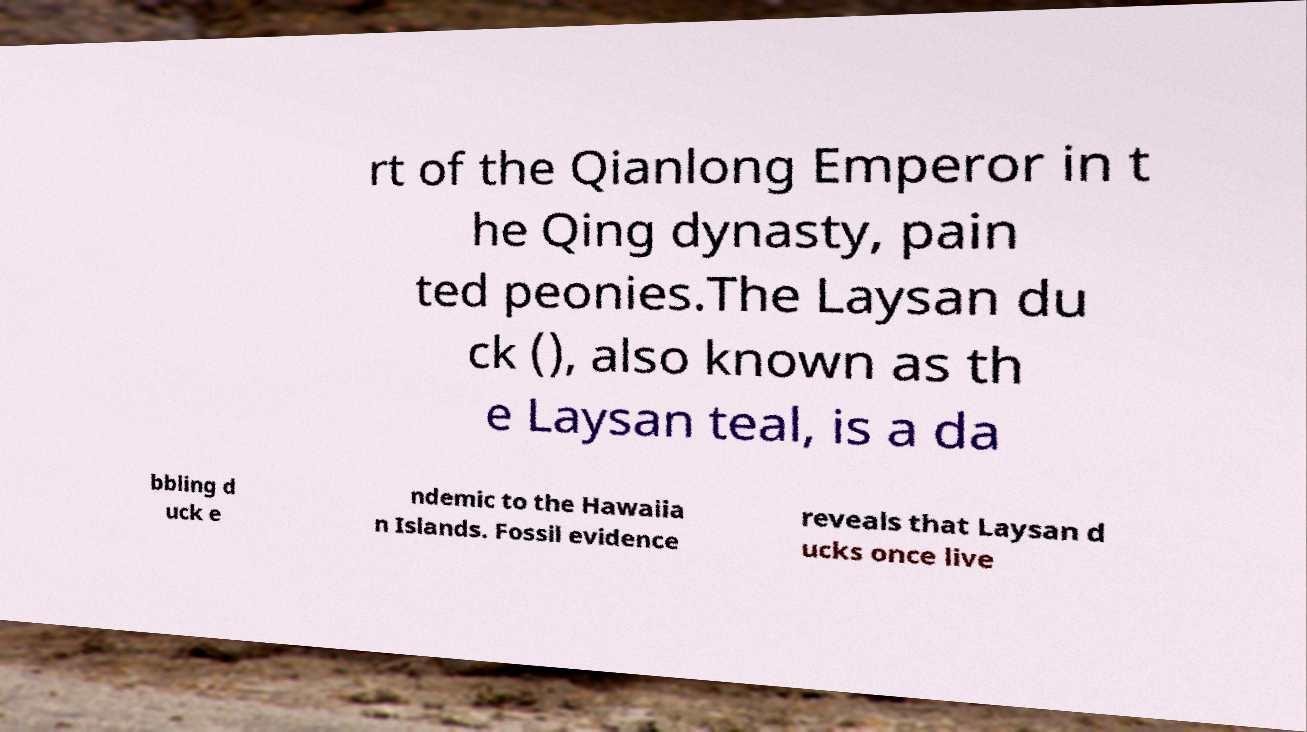Can you accurately transcribe the text from the provided image for me? rt of the Qianlong Emperor in t he Qing dynasty, pain ted peonies.The Laysan du ck (), also known as th e Laysan teal, is a da bbling d uck e ndemic to the Hawaiia n Islands. Fossil evidence reveals that Laysan d ucks once live 